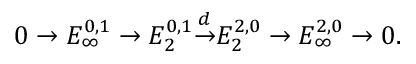<formula> <loc_0><loc_0><loc_500><loc_500>0 \to E _ { \infty } ^ { 0 , 1 } \to E _ { 2 } ^ { 0 , 1 } { \overset { d } { \to } } E _ { 2 } ^ { 2 , 0 } \to E _ { \infty } ^ { 2 , 0 } \to 0 .</formula> 